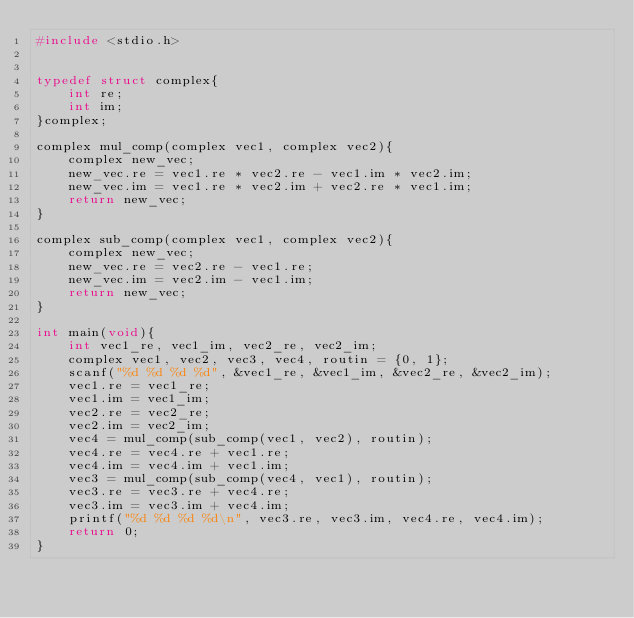<code> <loc_0><loc_0><loc_500><loc_500><_C_>#include <stdio.h>


typedef struct complex{
    int re;
    int im;
}complex;

complex mul_comp(complex vec1, complex vec2){
    complex new_vec;
    new_vec.re = vec1.re * vec2.re - vec1.im * vec2.im;
    new_vec.im = vec1.re * vec2.im + vec2.re * vec1.im;
    return new_vec;
}

complex sub_comp(complex vec1, complex vec2){
    complex new_vec;
    new_vec.re = vec2.re - vec1.re;
    new_vec.im = vec2.im - vec1.im;
    return new_vec;
}

int main(void){
    int vec1_re, vec1_im, vec2_re, vec2_im;
    complex vec1, vec2, vec3, vec4, routin = {0, 1};
    scanf("%d %d %d %d", &vec1_re, &vec1_im, &vec2_re, &vec2_im);
    vec1.re = vec1_re;
    vec1.im = vec1_im;
    vec2.re = vec2_re;
    vec2.im = vec2_im;
    vec4 = mul_comp(sub_comp(vec1, vec2), routin);
    vec4.re = vec4.re + vec1.re;
    vec4.im = vec4.im + vec1.im;
    vec3 = mul_comp(sub_comp(vec4, vec1), routin);
    vec3.re = vec3.re + vec4.re;
    vec3.im = vec3.im + vec4.im;
    printf("%d %d %d %d\n", vec3.re, vec3.im, vec4.re, vec4.im);
    return 0;
}</code> 